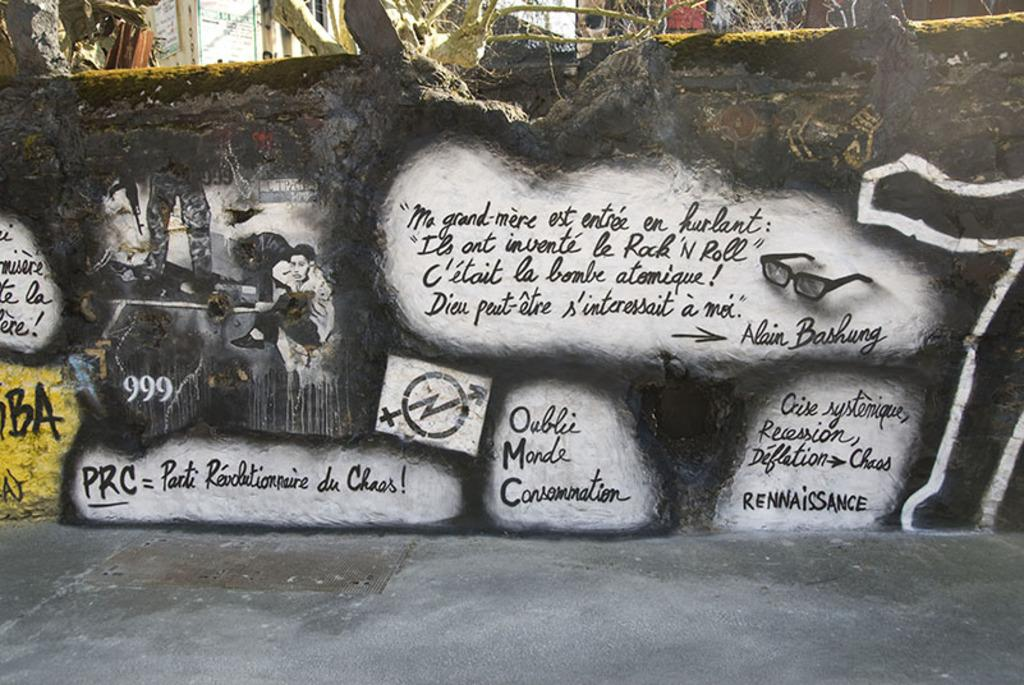What is written on the wall in the image? There is text written on the wall in the image. What can be seen in the background of the image? There are buildings visible in the background of the image. Can you describe the detail of the wire used in the battle scene in the image? There is no battle scene or wire present in the image; it features text written on a wall and buildings in the background. 